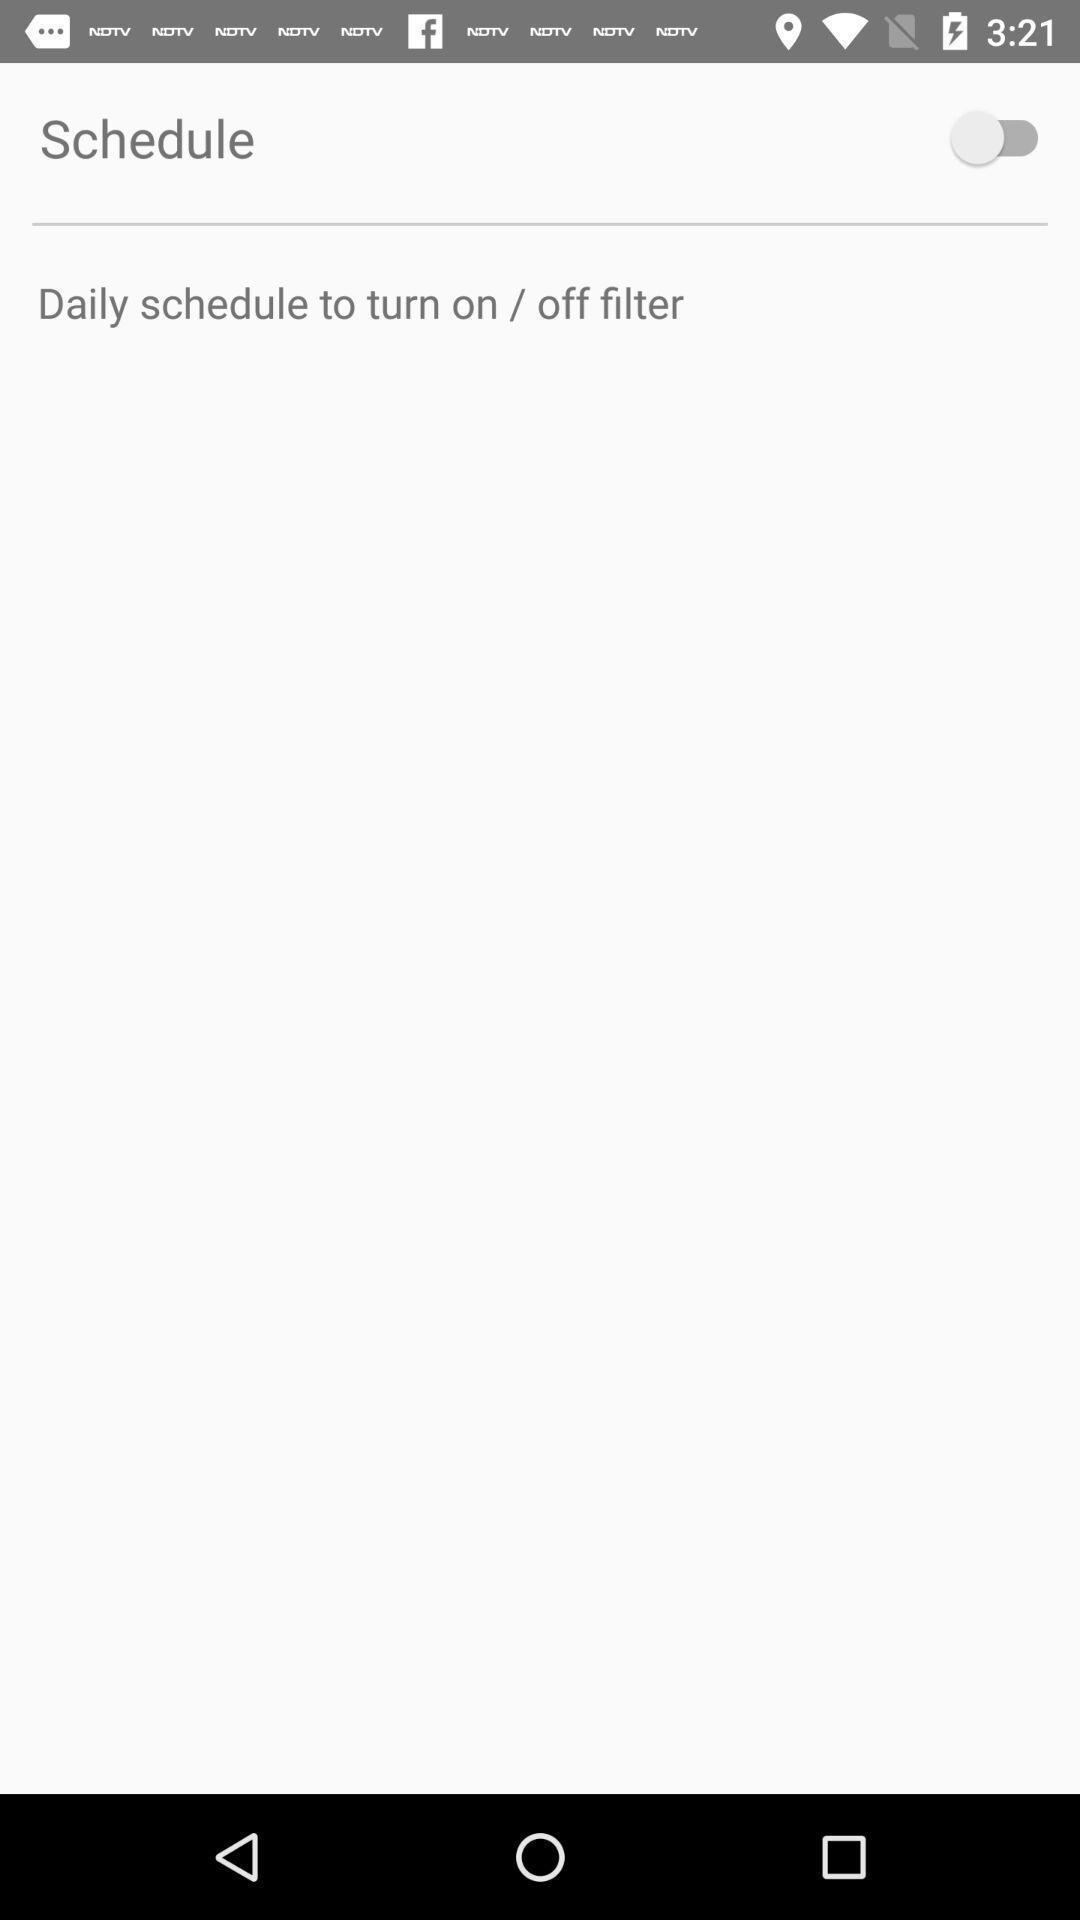Describe the key features of this screenshot. Screen displaying schedule setting option. 